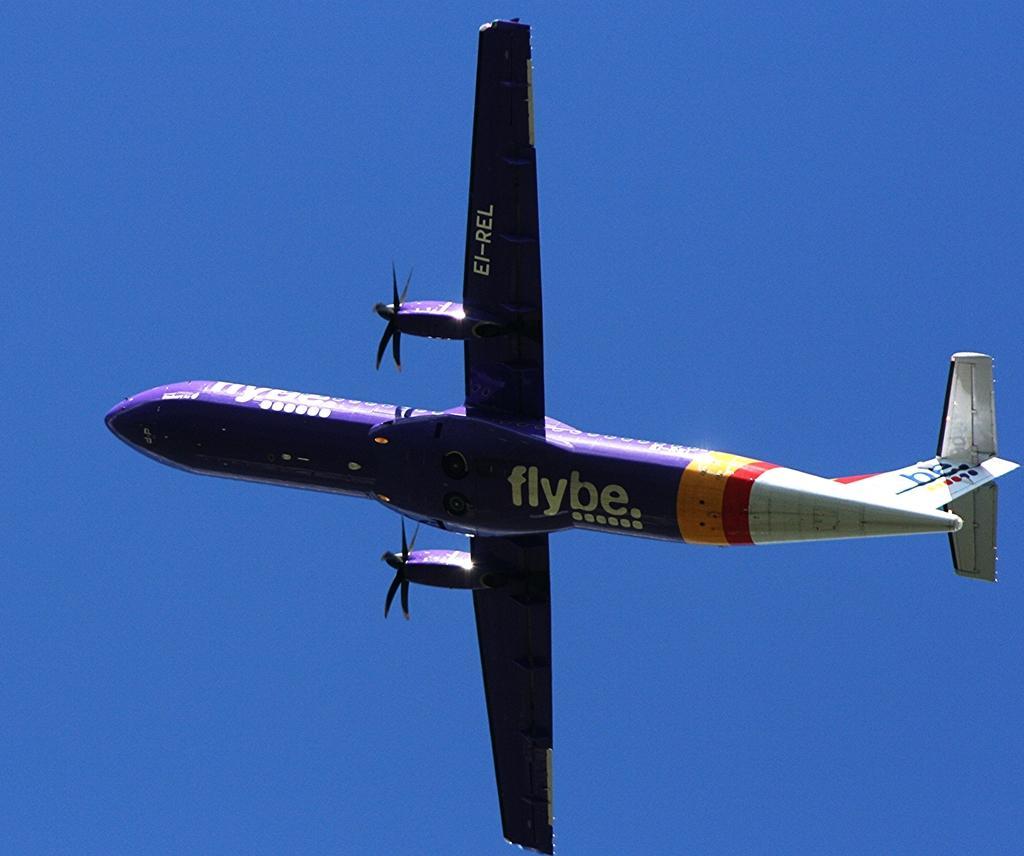Please provide a concise description of this image. In this image, we can see the background as blue in color and there is an aeroplane at the center. 